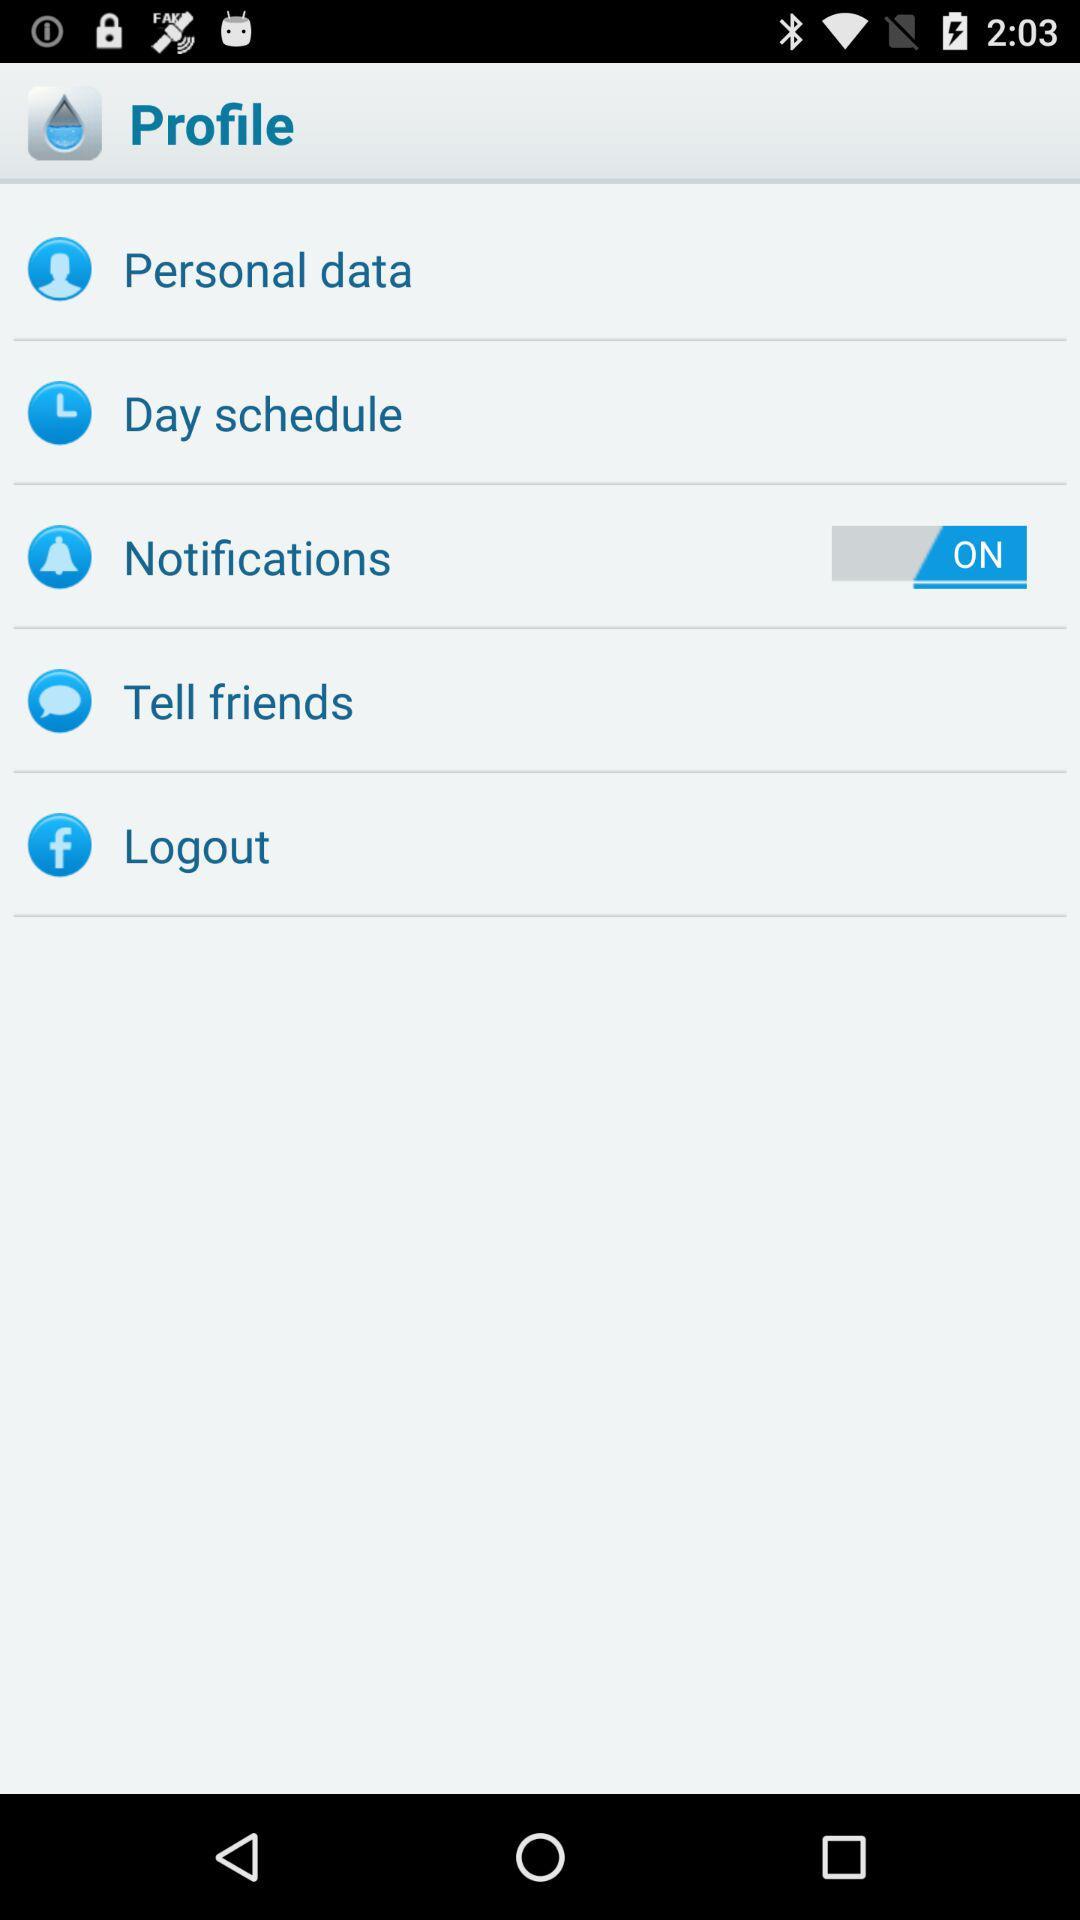What is the status of "Notifications"? The status of "Notifications" is "on". 